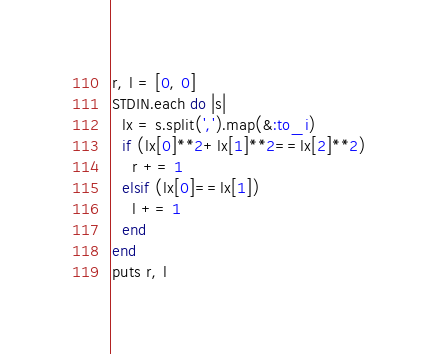<code> <loc_0><loc_0><loc_500><loc_500><_Ruby_>r, l = [0, 0]
STDIN.each do |s|
  lx = s.split(',').map(&:to_i)
  if (lx[0]**2+lx[1]**2==lx[2]**2)
    r += 1
  elsif (lx[0]==lx[1])
    l += 1
  end
end
puts r, l</code> 